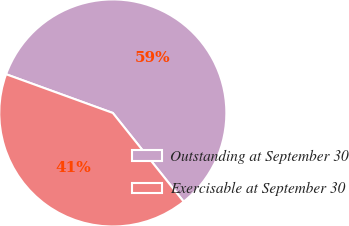Convert chart. <chart><loc_0><loc_0><loc_500><loc_500><pie_chart><fcel>Outstanding at September 30<fcel>Exercisable at September 30<nl><fcel>58.73%<fcel>41.27%<nl></chart> 